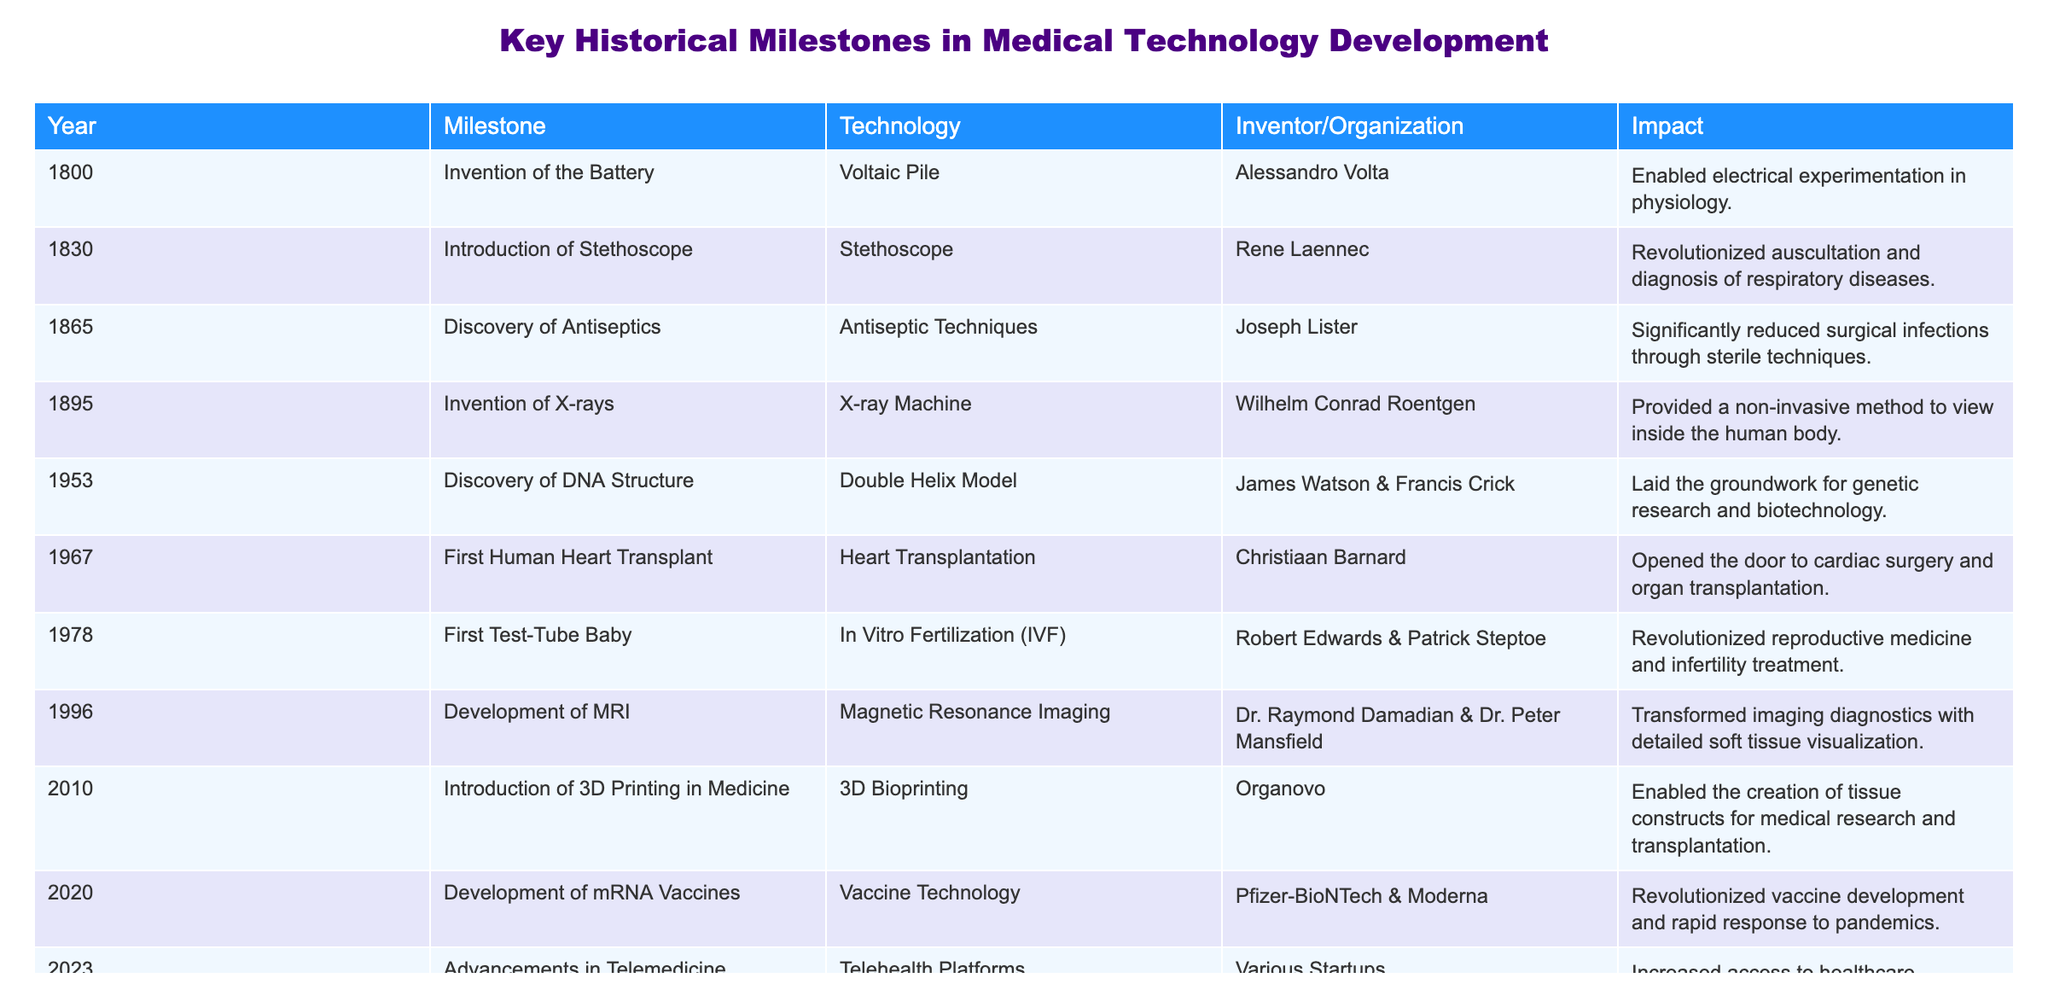What year was the first human heart transplant performed? The table indicates that the first human heart transplant occurred in the year 1967. This is evident in the row that specifically mentions this milestone.
Answer: 1967 Who invented the stethoscope? According to the table, the stethoscope was invented by Rene Laennec in 1830. This can be found in the corresponding row under the inventor/organization column.
Answer: Rene Laennec How many years passed between the invention of X-rays and the discovery of DNA structure? The invention of X-rays occurred in 1895 and the discovery of DNA structure was in 1953. Calculating the difference: 1953 - 1895 = 58 years.
Answer: 58 years Was the MRI development before the first test-tube baby? The table reveals that MRI was developed in 1996 and the first test-tube baby was born in 1978. Since 1996 is after 1978, the statement is false.
Answer: No What impact did the introduction of mRNA vaccines have on vaccine development? From the table, mRNA vaccines revolutionized vaccine development and enabled rapid response to pandemics, which is noted in the impact column of the relevant row for 2020.
Answer: Revolutionized vaccine development How many technologies mentioned were developed after 1950? The table lists technologies developed after 1950: heart transplantation (1967), IVF (1978), MRI (1996), 3D bioprinting (2010), mRNA vaccines (2020), and telemedicine (2023). Counting these gives a total of 6 technologies.
Answer: 6 technologies What was the major impact of the discovery of antiseptics? The table states that the discovery of antiseptics, credited to Joseph Lister in 1865, significantly reduced surgical infections through sterile techniques. This impact is specifically mentioned in the impact column.
Answer: Significantly reduced surgical infections List all milestones that involved imaging technology. Referring to the table, the milestones involving imaging technology are the invention of X-rays (1895) and the development of MRI (1996). This is indicated under the technology column for these years.
Answer: X-rays and MRI 